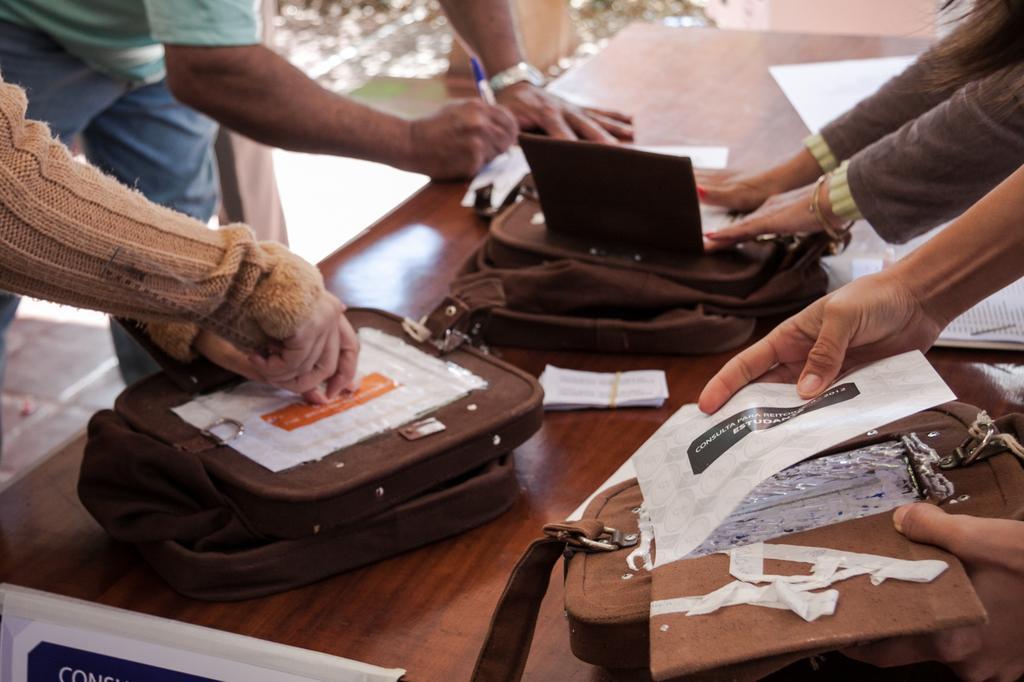Can you describe this image briefly? In this image I can see many human hands on the table. I can also see few bags in brown color and few papers on the table, and the table is in brown color. 